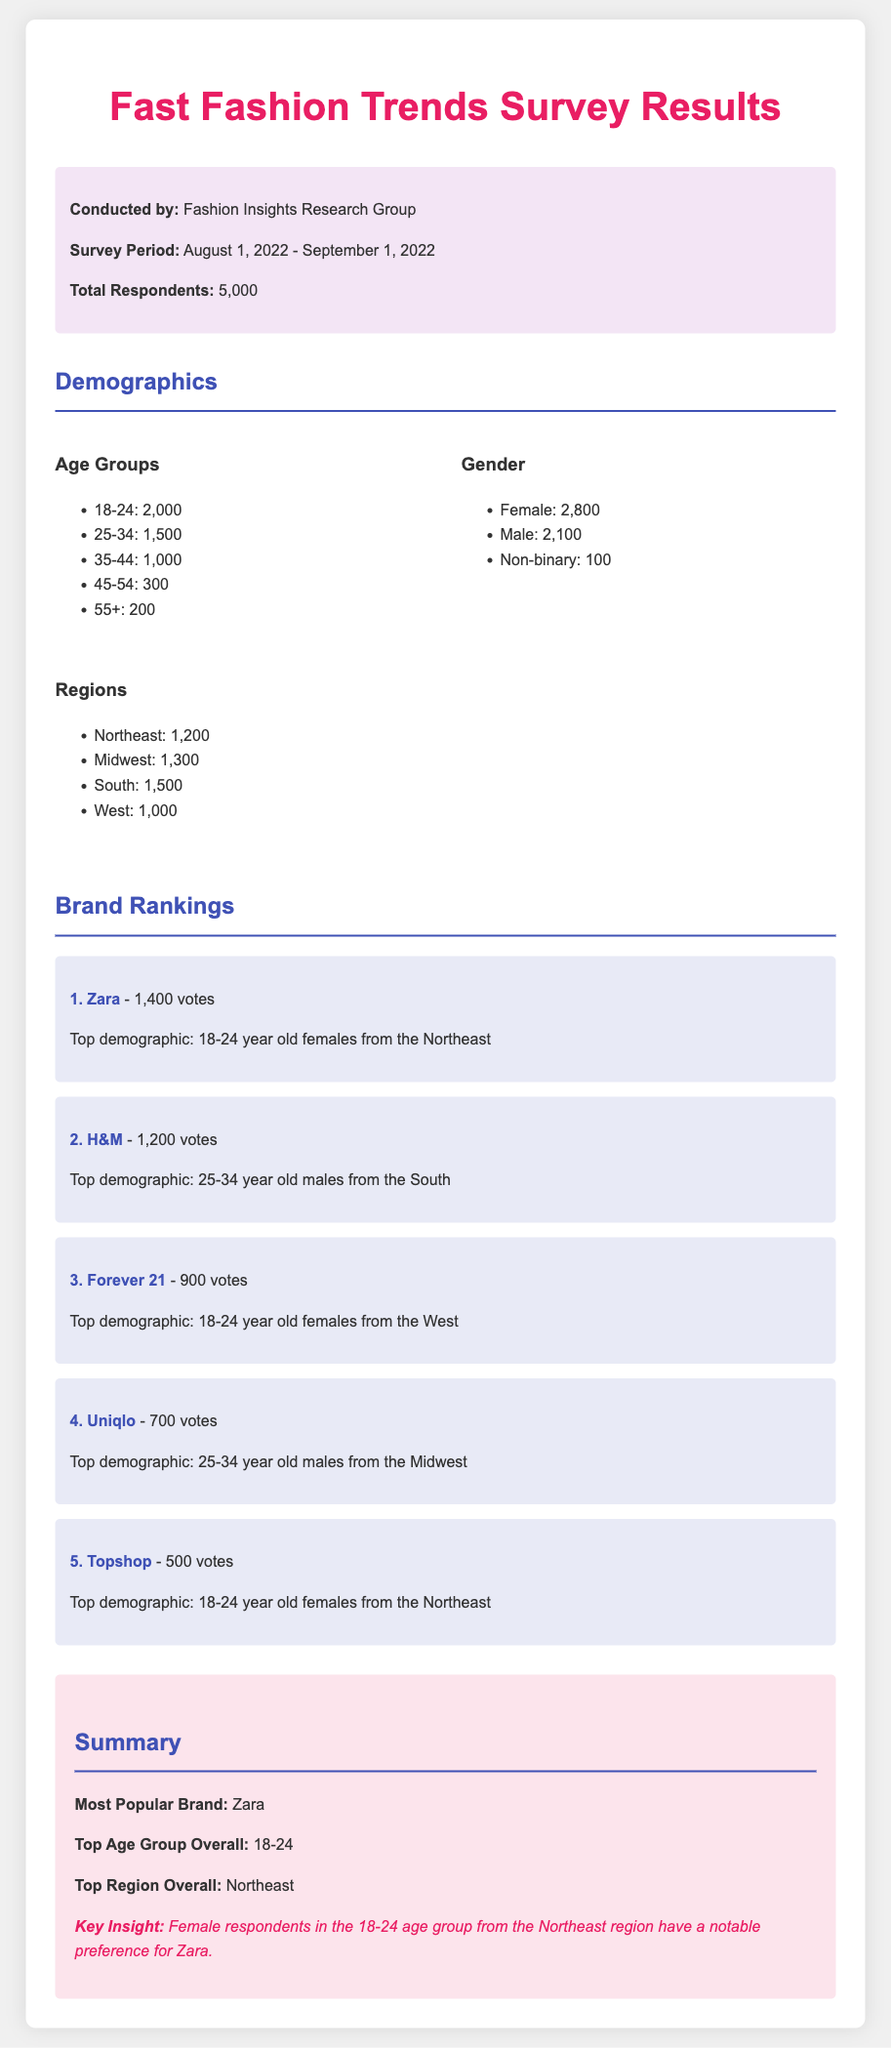What is the total number of respondents? The document states that the total number of respondents is 5,000.
Answer: 5,000 What is the top brand according to the survey? The summary in the document identifies Zara as the most popular brand.
Answer: Zara Which age group has the most respondents? The demographics section indicates that the 18-24 age group has 2,000 respondents, which is the highest.
Answer: 18-24 What percentage of respondents identify as female? From the demographics, 2,800 out of 5,000 respondents identify as female, which is 56%.
Answer: 56% What is the total number of votes for H&M? The brand ranking section provides that H&M received 1,200 votes.
Answer: 1,200 Which region has the highest number of respondents? The document lists the South with 1,500 respondents as the highest region.
Answer: South What age group is the top demographic for Forever 21? The brand ranking section reveals that the top demographic for Forever 21 is 18-24 year old females from the West.
Answer: 18-24 year old females from the West Which brand is ranked fourth in the survey? The brand rankings clearly state that Uniqlo is ranked fourth with 700 votes.
Answer: Uniqlo What is the key insight mentioned in the summary? The summary highlights that female respondents in the 18-24 age group from the Northeast region have a notable preference for Zara.
Answer: Female respondents in the 18-24 age group from the Northeast region have a notable preference for Zara 